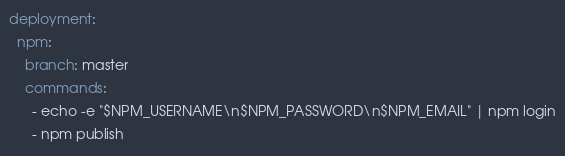Convert code to text. <code><loc_0><loc_0><loc_500><loc_500><_YAML_>deployment:
  npm:
    branch: master
    commands:
      - echo -e "$NPM_USERNAME\n$NPM_PASSWORD\n$NPM_EMAIL" | npm login
      - npm publish
</code> 